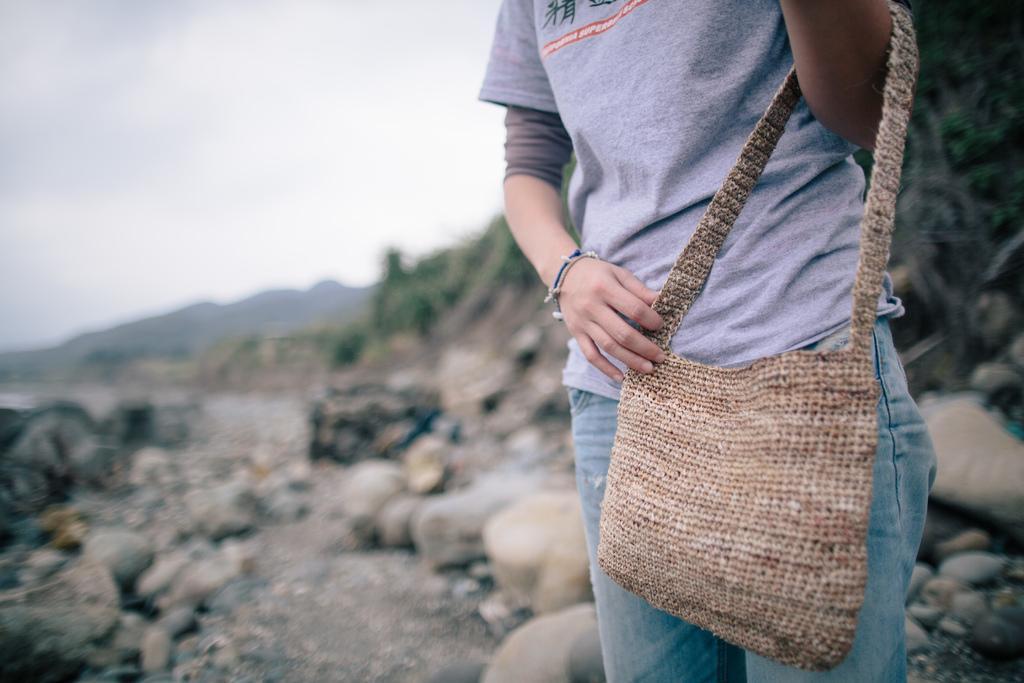Please provide a concise description of this image. As we can see in the image in the front there is a woman holding a bag. There are rocks, hills and sky. 